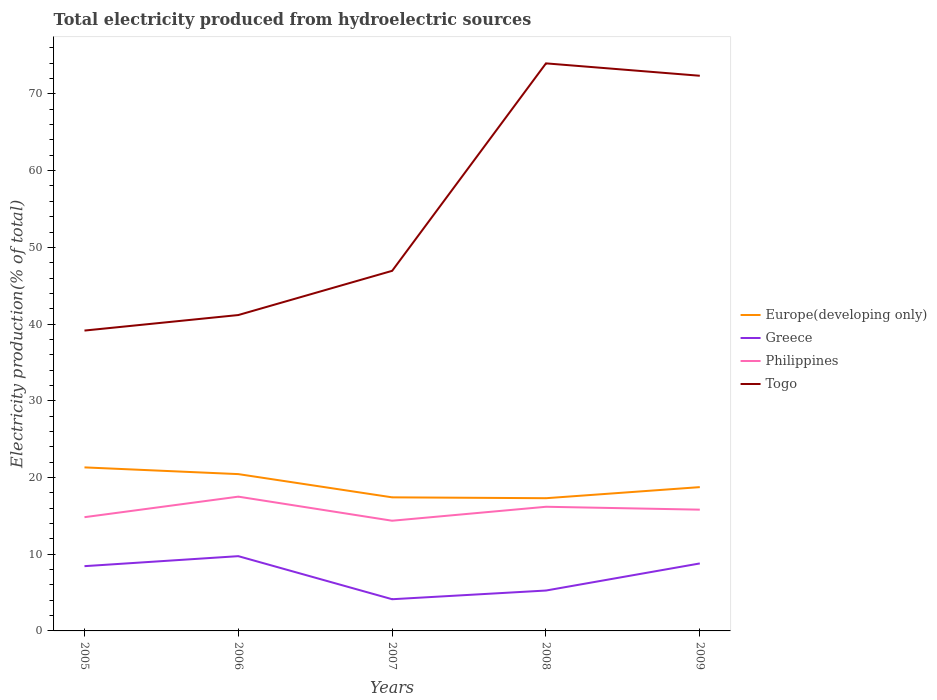How many different coloured lines are there?
Your answer should be very brief. 4. Does the line corresponding to Europe(developing only) intersect with the line corresponding to Togo?
Make the answer very short. No. Across all years, what is the maximum total electricity produced in Philippines?
Provide a succinct answer. 14.36. In which year was the total electricity produced in Philippines maximum?
Your answer should be compact. 2007. What is the total total electricity produced in Philippines in the graph?
Provide a short and direct response. -0.98. What is the difference between the highest and the second highest total electricity produced in Togo?
Offer a very short reply. 34.83. What is the difference between the highest and the lowest total electricity produced in Greece?
Your answer should be very brief. 3. Is the total electricity produced in Togo strictly greater than the total electricity produced in Philippines over the years?
Your answer should be very brief. No. How many lines are there?
Provide a short and direct response. 4. How many years are there in the graph?
Keep it short and to the point. 5. What is the difference between two consecutive major ticks on the Y-axis?
Your response must be concise. 10. Are the values on the major ticks of Y-axis written in scientific E-notation?
Ensure brevity in your answer.  No. Does the graph contain grids?
Your answer should be compact. No. How are the legend labels stacked?
Provide a short and direct response. Vertical. What is the title of the graph?
Ensure brevity in your answer.  Total electricity produced from hydroelectric sources. Does "Sudan" appear as one of the legend labels in the graph?
Offer a very short reply. No. What is the Electricity production(% of total) in Europe(developing only) in 2005?
Your answer should be compact. 21.32. What is the Electricity production(% of total) of Greece in 2005?
Ensure brevity in your answer.  8.44. What is the Electricity production(% of total) of Philippines in 2005?
Make the answer very short. 14.83. What is the Electricity production(% of total) in Togo in 2005?
Your answer should be very brief. 39.15. What is the Electricity production(% of total) in Europe(developing only) in 2006?
Offer a terse response. 20.44. What is the Electricity production(% of total) in Greece in 2006?
Provide a succinct answer. 9.75. What is the Electricity production(% of total) in Philippines in 2006?
Give a very brief answer. 17.5. What is the Electricity production(% of total) of Togo in 2006?
Ensure brevity in your answer.  41.18. What is the Electricity production(% of total) of Europe(developing only) in 2007?
Provide a succinct answer. 17.41. What is the Electricity production(% of total) of Greece in 2007?
Your answer should be compact. 4.13. What is the Electricity production(% of total) of Philippines in 2007?
Your answer should be very brief. 14.36. What is the Electricity production(% of total) in Togo in 2007?
Provide a short and direct response. 46.94. What is the Electricity production(% of total) in Europe(developing only) in 2008?
Your answer should be very brief. 17.3. What is the Electricity production(% of total) in Greece in 2008?
Your answer should be very brief. 5.26. What is the Electricity production(% of total) in Philippines in 2008?
Your answer should be very brief. 16.18. What is the Electricity production(% of total) in Togo in 2008?
Ensure brevity in your answer.  73.98. What is the Electricity production(% of total) of Europe(developing only) in 2009?
Make the answer very short. 18.74. What is the Electricity production(% of total) in Greece in 2009?
Your answer should be compact. 8.8. What is the Electricity production(% of total) of Philippines in 2009?
Make the answer very short. 15.81. What is the Electricity production(% of total) of Togo in 2009?
Your answer should be compact. 72.37. Across all years, what is the maximum Electricity production(% of total) of Europe(developing only)?
Provide a short and direct response. 21.32. Across all years, what is the maximum Electricity production(% of total) of Greece?
Provide a short and direct response. 9.75. Across all years, what is the maximum Electricity production(% of total) of Philippines?
Offer a terse response. 17.5. Across all years, what is the maximum Electricity production(% of total) in Togo?
Offer a very short reply. 73.98. Across all years, what is the minimum Electricity production(% of total) in Europe(developing only)?
Provide a succinct answer. 17.3. Across all years, what is the minimum Electricity production(% of total) of Greece?
Ensure brevity in your answer.  4.13. Across all years, what is the minimum Electricity production(% of total) of Philippines?
Your answer should be compact. 14.36. Across all years, what is the minimum Electricity production(% of total) of Togo?
Ensure brevity in your answer.  39.15. What is the total Electricity production(% of total) in Europe(developing only) in the graph?
Keep it short and to the point. 95.22. What is the total Electricity production(% of total) in Greece in the graph?
Ensure brevity in your answer.  36.38. What is the total Electricity production(% of total) in Philippines in the graph?
Keep it short and to the point. 78.69. What is the total Electricity production(% of total) in Togo in the graph?
Ensure brevity in your answer.  273.62. What is the difference between the Electricity production(% of total) in Europe(developing only) in 2005 and that in 2006?
Offer a very short reply. 0.88. What is the difference between the Electricity production(% of total) of Greece in 2005 and that in 2006?
Offer a very short reply. -1.3. What is the difference between the Electricity production(% of total) in Philippines in 2005 and that in 2006?
Your response must be concise. -2.68. What is the difference between the Electricity production(% of total) of Togo in 2005 and that in 2006?
Make the answer very short. -2.02. What is the difference between the Electricity production(% of total) in Europe(developing only) in 2005 and that in 2007?
Give a very brief answer. 3.91. What is the difference between the Electricity production(% of total) in Greece in 2005 and that in 2007?
Provide a short and direct response. 4.31. What is the difference between the Electricity production(% of total) of Philippines in 2005 and that in 2007?
Your answer should be compact. 0.46. What is the difference between the Electricity production(% of total) in Togo in 2005 and that in 2007?
Your response must be concise. -7.79. What is the difference between the Electricity production(% of total) in Europe(developing only) in 2005 and that in 2008?
Your response must be concise. 4.02. What is the difference between the Electricity production(% of total) in Greece in 2005 and that in 2008?
Give a very brief answer. 3.18. What is the difference between the Electricity production(% of total) of Philippines in 2005 and that in 2008?
Give a very brief answer. -1.36. What is the difference between the Electricity production(% of total) of Togo in 2005 and that in 2008?
Ensure brevity in your answer.  -34.83. What is the difference between the Electricity production(% of total) in Europe(developing only) in 2005 and that in 2009?
Your response must be concise. 2.57. What is the difference between the Electricity production(% of total) in Greece in 2005 and that in 2009?
Keep it short and to the point. -0.35. What is the difference between the Electricity production(% of total) of Philippines in 2005 and that in 2009?
Provide a succinct answer. -0.98. What is the difference between the Electricity production(% of total) of Togo in 2005 and that in 2009?
Make the answer very short. -33.22. What is the difference between the Electricity production(% of total) in Europe(developing only) in 2006 and that in 2007?
Give a very brief answer. 3.03. What is the difference between the Electricity production(% of total) of Greece in 2006 and that in 2007?
Ensure brevity in your answer.  5.61. What is the difference between the Electricity production(% of total) in Philippines in 2006 and that in 2007?
Make the answer very short. 3.14. What is the difference between the Electricity production(% of total) in Togo in 2006 and that in 2007?
Offer a terse response. -5.76. What is the difference between the Electricity production(% of total) of Europe(developing only) in 2006 and that in 2008?
Provide a succinct answer. 3.14. What is the difference between the Electricity production(% of total) in Greece in 2006 and that in 2008?
Provide a short and direct response. 4.48. What is the difference between the Electricity production(% of total) of Philippines in 2006 and that in 2008?
Ensure brevity in your answer.  1.32. What is the difference between the Electricity production(% of total) of Togo in 2006 and that in 2008?
Make the answer very short. -32.81. What is the difference between the Electricity production(% of total) in Europe(developing only) in 2006 and that in 2009?
Provide a short and direct response. 1.7. What is the difference between the Electricity production(% of total) of Greece in 2006 and that in 2009?
Your response must be concise. 0.95. What is the difference between the Electricity production(% of total) in Philippines in 2006 and that in 2009?
Provide a short and direct response. 1.7. What is the difference between the Electricity production(% of total) of Togo in 2006 and that in 2009?
Offer a terse response. -31.19. What is the difference between the Electricity production(% of total) in Europe(developing only) in 2007 and that in 2008?
Give a very brief answer. 0.11. What is the difference between the Electricity production(% of total) of Greece in 2007 and that in 2008?
Keep it short and to the point. -1.13. What is the difference between the Electricity production(% of total) of Philippines in 2007 and that in 2008?
Offer a terse response. -1.82. What is the difference between the Electricity production(% of total) of Togo in 2007 and that in 2008?
Your response must be concise. -27.05. What is the difference between the Electricity production(% of total) of Europe(developing only) in 2007 and that in 2009?
Provide a short and direct response. -1.33. What is the difference between the Electricity production(% of total) of Greece in 2007 and that in 2009?
Keep it short and to the point. -4.66. What is the difference between the Electricity production(% of total) in Philippines in 2007 and that in 2009?
Keep it short and to the point. -1.44. What is the difference between the Electricity production(% of total) in Togo in 2007 and that in 2009?
Provide a succinct answer. -25.43. What is the difference between the Electricity production(% of total) in Europe(developing only) in 2008 and that in 2009?
Give a very brief answer. -1.44. What is the difference between the Electricity production(% of total) in Greece in 2008 and that in 2009?
Provide a short and direct response. -3.53. What is the difference between the Electricity production(% of total) of Philippines in 2008 and that in 2009?
Offer a very short reply. 0.38. What is the difference between the Electricity production(% of total) of Togo in 2008 and that in 2009?
Provide a succinct answer. 1.62. What is the difference between the Electricity production(% of total) of Europe(developing only) in 2005 and the Electricity production(% of total) of Greece in 2006?
Keep it short and to the point. 11.57. What is the difference between the Electricity production(% of total) of Europe(developing only) in 2005 and the Electricity production(% of total) of Philippines in 2006?
Offer a very short reply. 3.81. What is the difference between the Electricity production(% of total) in Europe(developing only) in 2005 and the Electricity production(% of total) in Togo in 2006?
Offer a very short reply. -19.86. What is the difference between the Electricity production(% of total) in Greece in 2005 and the Electricity production(% of total) in Philippines in 2006?
Provide a succinct answer. -9.06. What is the difference between the Electricity production(% of total) of Greece in 2005 and the Electricity production(% of total) of Togo in 2006?
Provide a succinct answer. -32.73. What is the difference between the Electricity production(% of total) in Philippines in 2005 and the Electricity production(% of total) in Togo in 2006?
Offer a very short reply. -26.35. What is the difference between the Electricity production(% of total) of Europe(developing only) in 2005 and the Electricity production(% of total) of Greece in 2007?
Offer a terse response. 17.19. What is the difference between the Electricity production(% of total) of Europe(developing only) in 2005 and the Electricity production(% of total) of Philippines in 2007?
Your answer should be very brief. 6.95. What is the difference between the Electricity production(% of total) of Europe(developing only) in 2005 and the Electricity production(% of total) of Togo in 2007?
Provide a short and direct response. -25.62. What is the difference between the Electricity production(% of total) in Greece in 2005 and the Electricity production(% of total) in Philippines in 2007?
Your response must be concise. -5.92. What is the difference between the Electricity production(% of total) of Greece in 2005 and the Electricity production(% of total) of Togo in 2007?
Make the answer very short. -38.5. What is the difference between the Electricity production(% of total) in Philippines in 2005 and the Electricity production(% of total) in Togo in 2007?
Offer a very short reply. -32.11. What is the difference between the Electricity production(% of total) in Europe(developing only) in 2005 and the Electricity production(% of total) in Greece in 2008?
Provide a succinct answer. 16.05. What is the difference between the Electricity production(% of total) of Europe(developing only) in 2005 and the Electricity production(% of total) of Philippines in 2008?
Provide a short and direct response. 5.13. What is the difference between the Electricity production(% of total) in Europe(developing only) in 2005 and the Electricity production(% of total) in Togo in 2008?
Your response must be concise. -52.67. What is the difference between the Electricity production(% of total) in Greece in 2005 and the Electricity production(% of total) in Philippines in 2008?
Your response must be concise. -7.74. What is the difference between the Electricity production(% of total) in Greece in 2005 and the Electricity production(% of total) in Togo in 2008?
Ensure brevity in your answer.  -65.54. What is the difference between the Electricity production(% of total) of Philippines in 2005 and the Electricity production(% of total) of Togo in 2008?
Give a very brief answer. -59.16. What is the difference between the Electricity production(% of total) in Europe(developing only) in 2005 and the Electricity production(% of total) in Greece in 2009?
Ensure brevity in your answer.  12.52. What is the difference between the Electricity production(% of total) of Europe(developing only) in 2005 and the Electricity production(% of total) of Philippines in 2009?
Your response must be concise. 5.51. What is the difference between the Electricity production(% of total) in Europe(developing only) in 2005 and the Electricity production(% of total) in Togo in 2009?
Provide a short and direct response. -51.05. What is the difference between the Electricity production(% of total) in Greece in 2005 and the Electricity production(% of total) in Philippines in 2009?
Give a very brief answer. -7.36. What is the difference between the Electricity production(% of total) of Greece in 2005 and the Electricity production(% of total) of Togo in 2009?
Keep it short and to the point. -63.93. What is the difference between the Electricity production(% of total) in Philippines in 2005 and the Electricity production(% of total) in Togo in 2009?
Offer a very short reply. -57.54. What is the difference between the Electricity production(% of total) in Europe(developing only) in 2006 and the Electricity production(% of total) in Greece in 2007?
Your answer should be very brief. 16.31. What is the difference between the Electricity production(% of total) in Europe(developing only) in 2006 and the Electricity production(% of total) in Philippines in 2007?
Offer a terse response. 6.08. What is the difference between the Electricity production(% of total) in Europe(developing only) in 2006 and the Electricity production(% of total) in Togo in 2007?
Keep it short and to the point. -26.5. What is the difference between the Electricity production(% of total) in Greece in 2006 and the Electricity production(% of total) in Philippines in 2007?
Provide a short and direct response. -4.62. What is the difference between the Electricity production(% of total) of Greece in 2006 and the Electricity production(% of total) of Togo in 2007?
Offer a terse response. -37.19. What is the difference between the Electricity production(% of total) of Philippines in 2006 and the Electricity production(% of total) of Togo in 2007?
Provide a short and direct response. -29.44. What is the difference between the Electricity production(% of total) of Europe(developing only) in 2006 and the Electricity production(% of total) of Greece in 2008?
Offer a terse response. 15.18. What is the difference between the Electricity production(% of total) of Europe(developing only) in 2006 and the Electricity production(% of total) of Philippines in 2008?
Make the answer very short. 4.26. What is the difference between the Electricity production(% of total) in Europe(developing only) in 2006 and the Electricity production(% of total) in Togo in 2008?
Provide a succinct answer. -53.54. What is the difference between the Electricity production(% of total) in Greece in 2006 and the Electricity production(% of total) in Philippines in 2008?
Provide a succinct answer. -6.44. What is the difference between the Electricity production(% of total) in Greece in 2006 and the Electricity production(% of total) in Togo in 2008?
Your answer should be compact. -64.24. What is the difference between the Electricity production(% of total) of Philippines in 2006 and the Electricity production(% of total) of Togo in 2008?
Provide a short and direct response. -56.48. What is the difference between the Electricity production(% of total) of Europe(developing only) in 2006 and the Electricity production(% of total) of Greece in 2009?
Provide a short and direct response. 11.65. What is the difference between the Electricity production(% of total) of Europe(developing only) in 2006 and the Electricity production(% of total) of Philippines in 2009?
Offer a very short reply. 4.63. What is the difference between the Electricity production(% of total) of Europe(developing only) in 2006 and the Electricity production(% of total) of Togo in 2009?
Keep it short and to the point. -51.93. What is the difference between the Electricity production(% of total) of Greece in 2006 and the Electricity production(% of total) of Philippines in 2009?
Give a very brief answer. -6.06. What is the difference between the Electricity production(% of total) of Greece in 2006 and the Electricity production(% of total) of Togo in 2009?
Make the answer very short. -62.62. What is the difference between the Electricity production(% of total) in Philippines in 2006 and the Electricity production(% of total) in Togo in 2009?
Ensure brevity in your answer.  -54.86. What is the difference between the Electricity production(% of total) of Europe(developing only) in 2007 and the Electricity production(% of total) of Greece in 2008?
Give a very brief answer. 12.15. What is the difference between the Electricity production(% of total) of Europe(developing only) in 2007 and the Electricity production(% of total) of Philippines in 2008?
Your response must be concise. 1.23. What is the difference between the Electricity production(% of total) in Europe(developing only) in 2007 and the Electricity production(% of total) in Togo in 2008?
Provide a succinct answer. -56.57. What is the difference between the Electricity production(% of total) of Greece in 2007 and the Electricity production(% of total) of Philippines in 2008?
Offer a terse response. -12.05. What is the difference between the Electricity production(% of total) of Greece in 2007 and the Electricity production(% of total) of Togo in 2008?
Your answer should be compact. -69.85. What is the difference between the Electricity production(% of total) of Philippines in 2007 and the Electricity production(% of total) of Togo in 2008?
Provide a short and direct response. -59.62. What is the difference between the Electricity production(% of total) of Europe(developing only) in 2007 and the Electricity production(% of total) of Greece in 2009?
Your answer should be compact. 8.62. What is the difference between the Electricity production(% of total) in Europe(developing only) in 2007 and the Electricity production(% of total) in Philippines in 2009?
Offer a terse response. 1.61. What is the difference between the Electricity production(% of total) in Europe(developing only) in 2007 and the Electricity production(% of total) in Togo in 2009?
Keep it short and to the point. -54.96. What is the difference between the Electricity production(% of total) of Greece in 2007 and the Electricity production(% of total) of Philippines in 2009?
Keep it short and to the point. -11.68. What is the difference between the Electricity production(% of total) of Greece in 2007 and the Electricity production(% of total) of Togo in 2009?
Your response must be concise. -68.24. What is the difference between the Electricity production(% of total) of Philippines in 2007 and the Electricity production(% of total) of Togo in 2009?
Keep it short and to the point. -58. What is the difference between the Electricity production(% of total) in Europe(developing only) in 2008 and the Electricity production(% of total) in Greece in 2009?
Keep it short and to the point. 8.5. What is the difference between the Electricity production(% of total) of Europe(developing only) in 2008 and the Electricity production(% of total) of Philippines in 2009?
Offer a terse response. 1.49. What is the difference between the Electricity production(% of total) of Europe(developing only) in 2008 and the Electricity production(% of total) of Togo in 2009?
Offer a very short reply. -55.07. What is the difference between the Electricity production(% of total) of Greece in 2008 and the Electricity production(% of total) of Philippines in 2009?
Offer a terse response. -10.54. What is the difference between the Electricity production(% of total) in Greece in 2008 and the Electricity production(% of total) in Togo in 2009?
Give a very brief answer. -67.1. What is the difference between the Electricity production(% of total) of Philippines in 2008 and the Electricity production(% of total) of Togo in 2009?
Give a very brief answer. -56.18. What is the average Electricity production(% of total) in Europe(developing only) per year?
Provide a succinct answer. 19.04. What is the average Electricity production(% of total) in Greece per year?
Your response must be concise. 7.28. What is the average Electricity production(% of total) in Philippines per year?
Give a very brief answer. 15.74. What is the average Electricity production(% of total) of Togo per year?
Give a very brief answer. 54.72. In the year 2005, what is the difference between the Electricity production(% of total) in Europe(developing only) and Electricity production(% of total) in Greece?
Your answer should be compact. 12.88. In the year 2005, what is the difference between the Electricity production(% of total) in Europe(developing only) and Electricity production(% of total) in Philippines?
Your response must be concise. 6.49. In the year 2005, what is the difference between the Electricity production(% of total) of Europe(developing only) and Electricity production(% of total) of Togo?
Ensure brevity in your answer.  -17.84. In the year 2005, what is the difference between the Electricity production(% of total) in Greece and Electricity production(% of total) in Philippines?
Keep it short and to the point. -6.38. In the year 2005, what is the difference between the Electricity production(% of total) in Greece and Electricity production(% of total) in Togo?
Your answer should be very brief. -30.71. In the year 2005, what is the difference between the Electricity production(% of total) of Philippines and Electricity production(% of total) of Togo?
Offer a very short reply. -24.33. In the year 2006, what is the difference between the Electricity production(% of total) in Europe(developing only) and Electricity production(% of total) in Greece?
Give a very brief answer. 10.7. In the year 2006, what is the difference between the Electricity production(% of total) of Europe(developing only) and Electricity production(% of total) of Philippines?
Offer a very short reply. 2.94. In the year 2006, what is the difference between the Electricity production(% of total) of Europe(developing only) and Electricity production(% of total) of Togo?
Your answer should be compact. -20.73. In the year 2006, what is the difference between the Electricity production(% of total) in Greece and Electricity production(% of total) in Philippines?
Provide a succinct answer. -7.76. In the year 2006, what is the difference between the Electricity production(% of total) in Greece and Electricity production(% of total) in Togo?
Ensure brevity in your answer.  -31.43. In the year 2006, what is the difference between the Electricity production(% of total) in Philippines and Electricity production(% of total) in Togo?
Offer a terse response. -23.67. In the year 2007, what is the difference between the Electricity production(% of total) in Europe(developing only) and Electricity production(% of total) in Greece?
Provide a succinct answer. 13.28. In the year 2007, what is the difference between the Electricity production(% of total) in Europe(developing only) and Electricity production(% of total) in Philippines?
Your answer should be very brief. 3.05. In the year 2007, what is the difference between the Electricity production(% of total) in Europe(developing only) and Electricity production(% of total) in Togo?
Offer a terse response. -29.53. In the year 2007, what is the difference between the Electricity production(% of total) in Greece and Electricity production(% of total) in Philippines?
Ensure brevity in your answer.  -10.23. In the year 2007, what is the difference between the Electricity production(% of total) in Greece and Electricity production(% of total) in Togo?
Give a very brief answer. -42.81. In the year 2007, what is the difference between the Electricity production(% of total) in Philippines and Electricity production(% of total) in Togo?
Your answer should be very brief. -32.57. In the year 2008, what is the difference between the Electricity production(% of total) in Europe(developing only) and Electricity production(% of total) in Greece?
Offer a terse response. 12.04. In the year 2008, what is the difference between the Electricity production(% of total) in Europe(developing only) and Electricity production(% of total) in Philippines?
Offer a terse response. 1.12. In the year 2008, what is the difference between the Electricity production(% of total) of Europe(developing only) and Electricity production(% of total) of Togo?
Offer a terse response. -56.68. In the year 2008, what is the difference between the Electricity production(% of total) of Greece and Electricity production(% of total) of Philippines?
Ensure brevity in your answer.  -10.92. In the year 2008, what is the difference between the Electricity production(% of total) of Greece and Electricity production(% of total) of Togo?
Offer a terse response. -68.72. In the year 2008, what is the difference between the Electricity production(% of total) of Philippines and Electricity production(% of total) of Togo?
Offer a terse response. -57.8. In the year 2009, what is the difference between the Electricity production(% of total) of Europe(developing only) and Electricity production(% of total) of Greece?
Provide a succinct answer. 9.95. In the year 2009, what is the difference between the Electricity production(% of total) of Europe(developing only) and Electricity production(% of total) of Philippines?
Provide a succinct answer. 2.94. In the year 2009, what is the difference between the Electricity production(% of total) of Europe(developing only) and Electricity production(% of total) of Togo?
Provide a short and direct response. -53.62. In the year 2009, what is the difference between the Electricity production(% of total) of Greece and Electricity production(% of total) of Philippines?
Keep it short and to the point. -7.01. In the year 2009, what is the difference between the Electricity production(% of total) of Greece and Electricity production(% of total) of Togo?
Provide a short and direct response. -63.57. In the year 2009, what is the difference between the Electricity production(% of total) in Philippines and Electricity production(% of total) in Togo?
Offer a very short reply. -56.56. What is the ratio of the Electricity production(% of total) in Europe(developing only) in 2005 to that in 2006?
Give a very brief answer. 1.04. What is the ratio of the Electricity production(% of total) of Greece in 2005 to that in 2006?
Your answer should be very brief. 0.87. What is the ratio of the Electricity production(% of total) of Philippines in 2005 to that in 2006?
Make the answer very short. 0.85. What is the ratio of the Electricity production(% of total) of Togo in 2005 to that in 2006?
Your response must be concise. 0.95. What is the ratio of the Electricity production(% of total) of Europe(developing only) in 2005 to that in 2007?
Offer a terse response. 1.22. What is the ratio of the Electricity production(% of total) of Greece in 2005 to that in 2007?
Offer a very short reply. 2.04. What is the ratio of the Electricity production(% of total) of Philippines in 2005 to that in 2007?
Your answer should be very brief. 1.03. What is the ratio of the Electricity production(% of total) in Togo in 2005 to that in 2007?
Your answer should be compact. 0.83. What is the ratio of the Electricity production(% of total) of Europe(developing only) in 2005 to that in 2008?
Your response must be concise. 1.23. What is the ratio of the Electricity production(% of total) of Greece in 2005 to that in 2008?
Keep it short and to the point. 1.6. What is the ratio of the Electricity production(% of total) in Philippines in 2005 to that in 2008?
Offer a terse response. 0.92. What is the ratio of the Electricity production(% of total) in Togo in 2005 to that in 2008?
Make the answer very short. 0.53. What is the ratio of the Electricity production(% of total) in Europe(developing only) in 2005 to that in 2009?
Offer a very short reply. 1.14. What is the ratio of the Electricity production(% of total) in Greece in 2005 to that in 2009?
Keep it short and to the point. 0.96. What is the ratio of the Electricity production(% of total) in Philippines in 2005 to that in 2009?
Keep it short and to the point. 0.94. What is the ratio of the Electricity production(% of total) of Togo in 2005 to that in 2009?
Ensure brevity in your answer.  0.54. What is the ratio of the Electricity production(% of total) of Europe(developing only) in 2006 to that in 2007?
Give a very brief answer. 1.17. What is the ratio of the Electricity production(% of total) of Greece in 2006 to that in 2007?
Keep it short and to the point. 2.36. What is the ratio of the Electricity production(% of total) of Philippines in 2006 to that in 2007?
Provide a short and direct response. 1.22. What is the ratio of the Electricity production(% of total) in Togo in 2006 to that in 2007?
Your answer should be very brief. 0.88. What is the ratio of the Electricity production(% of total) in Europe(developing only) in 2006 to that in 2008?
Offer a terse response. 1.18. What is the ratio of the Electricity production(% of total) of Greece in 2006 to that in 2008?
Provide a short and direct response. 1.85. What is the ratio of the Electricity production(% of total) in Philippines in 2006 to that in 2008?
Offer a very short reply. 1.08. What is the ratio of the Electricity production(% of total) in Togo in 2006 to that in 2008?
Your answer should be very brief. 0.56. What is the ratio of the Electricity production(% of total) in Europe(developing only) in 2006 to that in 2009?
Offer a very short reply. 1.09. What is the ratio of the Electricity production(% of total) of Greece in 2006 to that in 2009?
Ensure brevity in your answer.  1.11. What is the ratio of the Electricity production(% of total) of Philippines in 2006 to that in 2009?
Make the answer very short. 1.11. What is the ratio of the Electricity production(% of total) of Togo in 2006 to that in 2009?
Your answer should be compact. 0.57. What is the ratio of the Electricity production(% of total) of Greece in 2007 to that in 2008?
Provide a short and direct response. 0.78. What is the ratio of the Electricity production(% of total) in Philippines in 2007 to that in 2008?
Your answer should be very brief. 0.89. What is the ratio of the Electricity production(% of total) of Togo in 2007 to that in 2008?
Your response must be concise. 0.63. What is the ratio of the Electricity production(% of total) of Europe(developing only) in 2007 to that in 2009?
Give a very brief answer. 0.93. What is the ratio of the Electricity production(% of total) of Greece in 2007 to that in 2009?
Give a very brief answer. 0.47. What is the ratio of the Electricity production(% of total) of Philippines in 2007 to that in 2009?
Make the answer very short. 0.91. What is the ratio of the Electricity production(% of total) in Togo in 2007 to that in 2009?
Your answer should be compact. 0.65. What is the ratio of the Electricity production(% of total) of Europe(developing only) in 2008 to that in 2009?
Offer a very short reply. 0.92. What is the ratio of the Electricity production(% of total) in Greece in 2008 to that in 2009?
Ensure brevity in your answer.  0.6. What is the ratio of the Electricity production(% of total) of Philippines in 2008 to that in 2009?
Your answer should be very brief. 1.02. What is the ratio of the Electricity production(% of total) in Togo in 2008 to that in 2009?
Offer a terse response. 1.02. What is the difference between the highest and the second highest Electricity production(% of total) of Europe(developing only)?
Ensure brevity in your answer.  0.88. What is the difference between the highest and the second highest Electricity production(% of total) of Greece?
Your answer should be very brief. 0.95. What is the difference between the highest and the second highest Electricity production(% of total) of Philippines?
Keep it short and to the point. 1.32. What is the difference between the highest and the second highest Electricity production(% of total) in Togo?
Your answer should be very brief. 1.62. What is the difference between the highest and the lowest Electricity production(% of total) of Europe(developing only)?
Ensure brevity in your answer.  4.02. What is the difference between the highest and the lowest Electricity production(% of total) in Greece?
Provide a succinct answer. 5.61. What is the difference between the highest and the lowest Electricity production(% of total) of Philippines?
Provide a short and direct response. 3.14. What is the difference between the highest and the lowest Electricity production(% of total) in Togo?
Your answer should be compact. 34.83. 